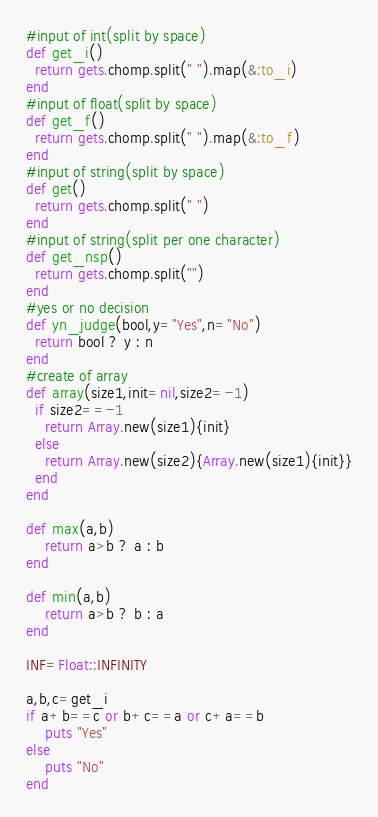<code> <loc_0><loc_0><loc_500><loc_500><_Ruby_>#input of int(split by space)
def get_i()
  return gets.chomp.split(" ").map(&:to_i)
end
#input of float(split by space)
def get_f()
  return gets.chomp.split(" ").map(&:to_f)
end
#input of string(split by space)
def get()
  return gets.chomp.split(" ")
end
#input of string(split per one character)
def get_nsp()
  return gets.chomp.split("")
end
#yes or no decision
def yn_judge(bool,y="Yes",n="No")
  return bool ? y : n 
end
#create of array
def array(size1,init=nil,size2=-1)
  if size2==-1
    return Array.new(size1){init}
  else
    return Array.new(size2){Array.new(size1){init}}
  end
end

def max(a,b)
    return a>b ? a : b
end

def min(a,b)
    return a>b ? b : a
end

INF=Float::INFINITY

a,b,c=get_i
if a+b==c or b+c==a or c+a==b
    puts "Yes"
else
    puts "No"
end</code> 